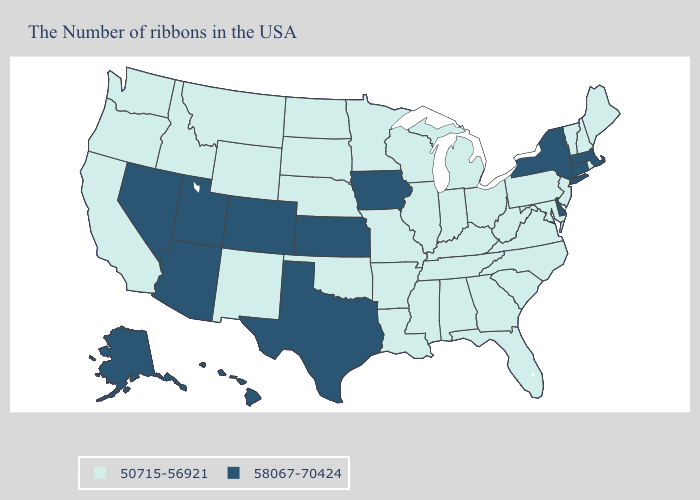Does Michigan have the same value as Illinois?
Write a very short answer. Yes. Name the states that have a value in the range 50715-56921?
Short answer required. Maine, Rhode Island, New Hampshire, Vermont, New Jersey, Maryland, Pennsylvania, Virginia, North Carolina, South Carolina, West Virginia, Ohio, Florida, Georgia, Michigan, Kentucky, Indiana, Alabama, Tennessee, Wisconsin, Illinois, Mississippi, Louisiana, Missouri, Arkansas, Minnesota, Nebraska, Oklahoma, South Dakota, North Dakota, Wyoming, New Mexico, Montana, Idaho, California, Washington, Oregon. What is the value of Nevada?
Quick response, please. 58067-70424. Among the states that border Minnesota , does Wisconsin have the lowest value?
Keep it brief. Yes. What is the value of Virginia?
Keep it brief. 50715-56921. Name the states that have a value in the range 58067-70424?
Answer briefly. Massachusetts, Connecticut, New York, Delaware, Iowa, Kansas, Texas, Colorado, Utah, Arizona, Nevada, Alaska, Hawaii. What is the value of Arizona?
Be succinct. 58067-70424. What is the value of Alabama?
Short answer required. 50715-56921. What is the value of Minnesota?
Concise answer only. 50715-56921. What is the highest value in the Northeast ?
Keep it brief. 58067-70424. Name the states that have a value in the range 50715-56921?
Give a very brief answer. Maine, Rhode Island, New Hampshire, Vermont, New Jersey, Maryland, Pennsylvania, Virginia, North Carolina, South Carolina, West Virginia, Ohio, Florida, Georgia, Michigan, Kentucky, Indiana, Alabama, Tennessee, Wisconsin, Illinois, Mississippi, Louisiana, Missouri, Arkansas, Minnesota, Nebraska, Oklahoma, South Dakota, North Dakota, Wyoming, New Mexico, Montana, Idaho, California, Washington, Oregon. Is the legend a continuous bar?
Quick response, please. No. What is the lowest value in the USA?
Keep it brief. 50715-56921. Which states hav the highest value in the South?
Give a very brief answer. Delaware, Texas. 